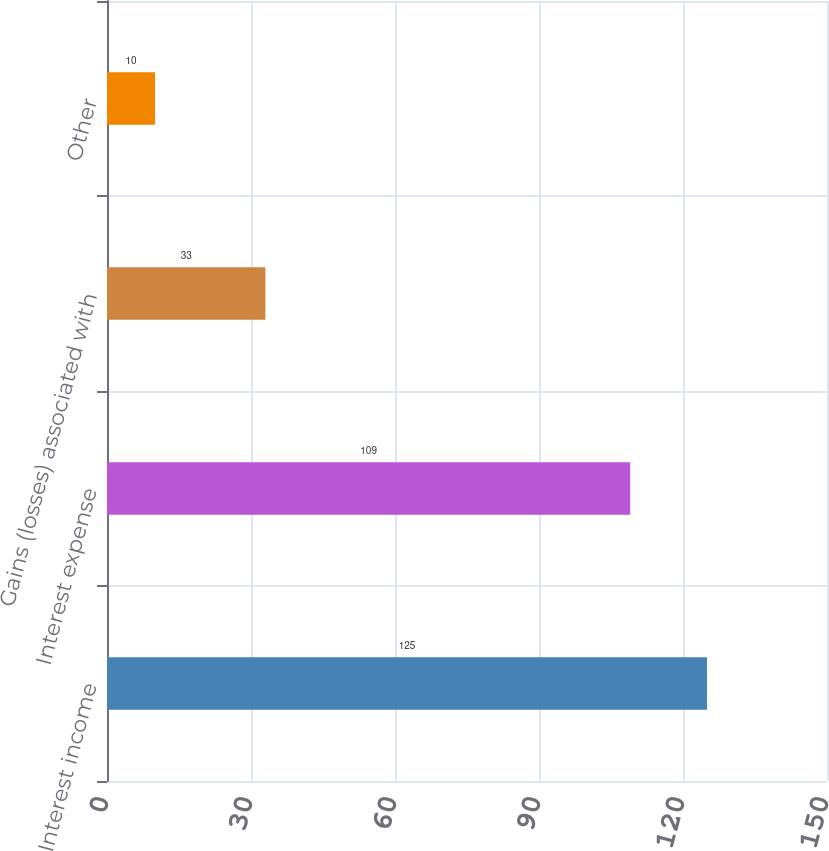<chart> <loc_0><loc_0><loc_500><loc_500><bar_chart><fcel>Interest income<fcel>Interest expense<fcel>Gains (losses) associated with<fcel>Other<nl><fcel>125<fcel>109<fcel>33<fcel>10<nl></chart> 